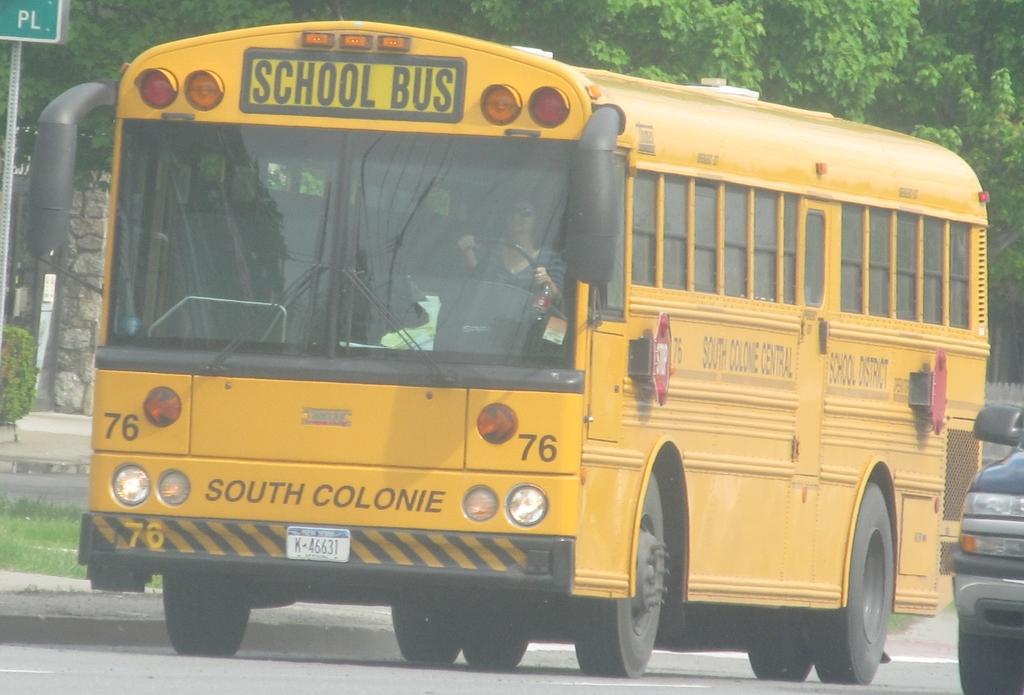What type of bus is it?
Offer a very short reply. School bus. 